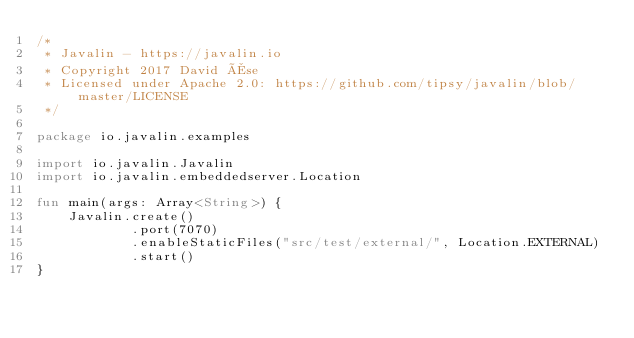Convert code to text. <code><loc_0><loc_0><loc_500><loc_500><_Kotlin_>/*
 * Javalin - https://javalin.io
 * Copyright 2017 David Åse
 * Licensed under Apache 2.0: https://github.com/tipsy/javalin/blob/master/LICENSE
 */

package io.javalin.examples

import io.javalin.Javalin
import io.javalin.embeddedserver.Location

fun main(args: Array<String>) {
    Javalin.create()
            .port(7070)
            .enableStaticFiles("src/test/external/", Location.EXTERNAL)
            .start()
}
</code> 